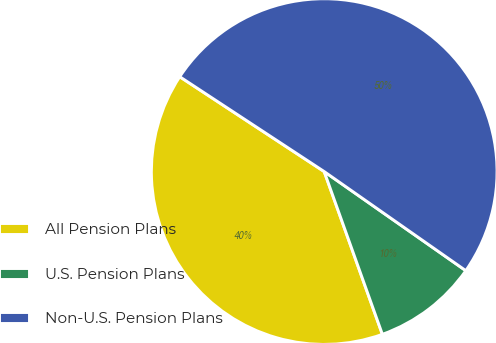Convert chart to OTSL. <chart><loc_0><loc_0><loc_500><loc_500><pie_chart><fcel>All Pension Plans<fcel>U.S. Pension Plans<fcel>Non-U.S. Pension Plans<nl><fcel>39.71%<fcel>9.82%<fcel>50.47%<nl></chart> 